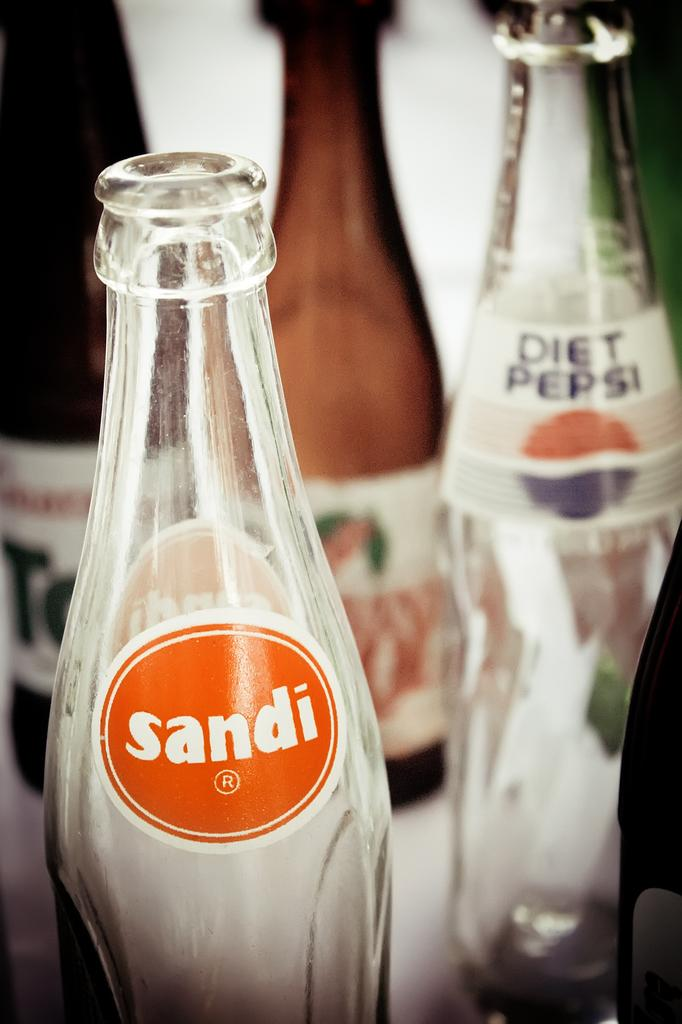<image>
Present a compact description of the photo's key features. Empty bottles of soda from different brands are on a table. 